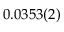<formula> <loc_0><loc_0><loc_500><loc_500>0 . 0 3 5 3 ( 2 )</formula> 